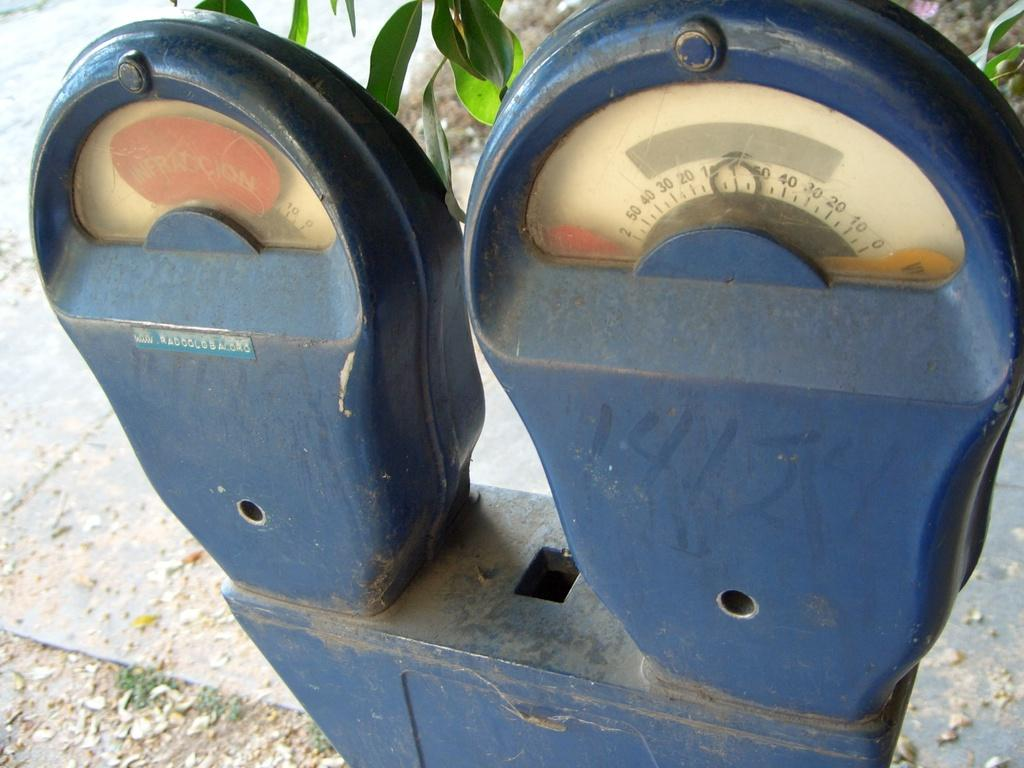<image>
Write a terse but informative summary of the picture. The circle on the meter on the right sits at the number 1/ 